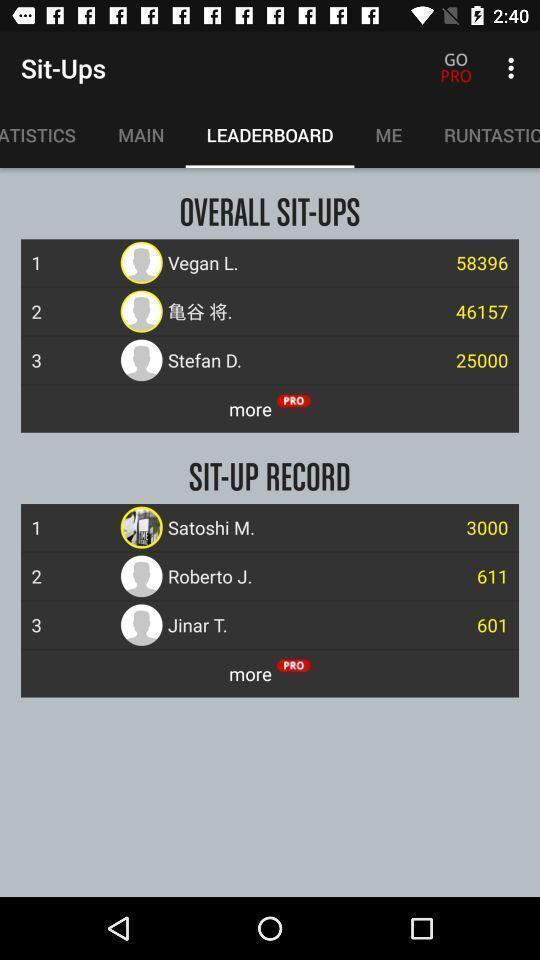Describe the key features of this screenshot. Statistics page. 